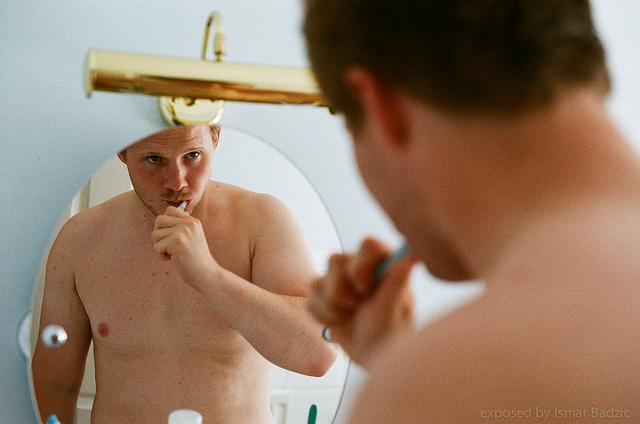What is this activity good for? teeth 